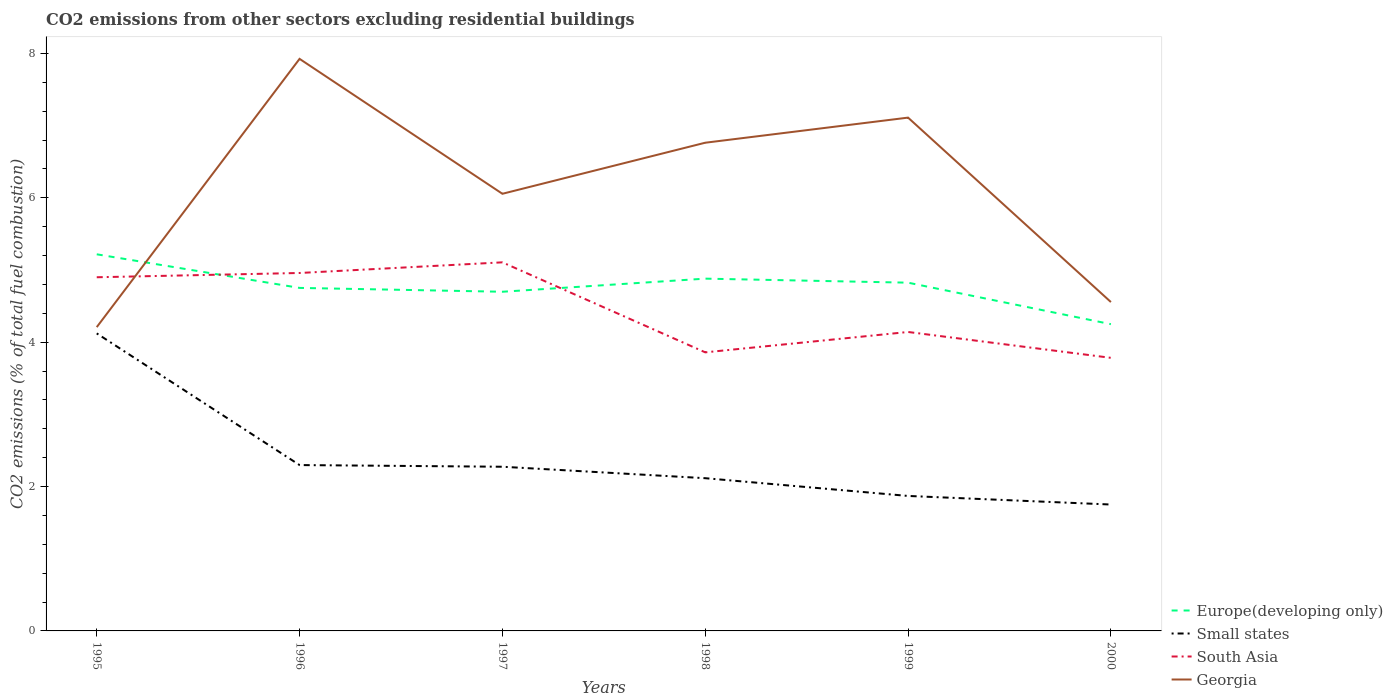Does the line corresponding to Europe(developing only) intersect with the line corresponding to Small states?
Give a very brief answer. No. Is the number of lines equal to the number of legend labels?
Ensure brevity in your answer.  Yes. Across all years, what is the maximum total CO2 emitted in Small states?
Provide a short and direct response. 1.75. In which year was the total CO2 emitted in Small states maximum?
Offer a very short reply. 2000. What is the total total CO2 emitted in South Asia in the graph?
Offer a very short reply. 0.36. What is the difference between the highest and the second highest total CO2 emitted in South Asia?
Offer a terse response. 1.32. Is the total CO2 emitted in Europe(developing only) strictly greater than the total CO2 emitted in Small states over the years?
Provide a succinct answer. No. How many lines are there?
Offer a very short reply. 4. How many years are there in the graph?
Your answer should be compact. 6. What is the difference between two consecutive major ticks on the Y-axis?
Your answer should be very brief. 2. Are the values on the major ticks of Y-axis written in scientific E-notation?
Provide a succinct answer. No. Does the graph contain any zero values?
Ensure brevity in your answer.  No. Where does the legend appear in the graph?
Give a very brief answer. Bottom right. How are the legend labels stacked?
Your answer should be very brief. Vertical. What is the title of the graph?
Provide a succinct answer. CO2 emissions from other sectors excluding residential buildings. Does "East Asia (all income levels)" appear as one of the legend labels in the graph?
Your answer should be compact. No. What is the label or title of the Y-axis?
Keep it short and to the point. CO2 emissions (% of total fuel combustion). What is the CO2 emissions (% of total fuel combustion) in Europe(developing only) in 1995?
Keep it short and to the point. 5.22. What is the CO2 emissions (% of total fuel combustion) of Small states in 1995?
Your response must be concise. 4.12. What is the CO2 emissions (% of total fuel combustion) of South Asia in 1995?
Give a very brief answer. 4.9. What is the CO2 emissions (% of total fuel combustion) in Georgia in 1995?
Your answer should be compact. 4.21. What is the CO2 emissions (% of total fuel combustion) in Europe(developing only) in 1996?
Offer a very short reply. 4.75. What is the CO2 emissions (% of total fuel combustion) in Small states in 1996?
Offer a very short reply. 2.3. What is the CO2 emissions (% of total fuel combustion) of South Asia in 1996?
Your response must be concise. 4.96. What is the CO2 emissions (% of total fuel combustion) in Georgia in 1996?
Your response must be concise. 7.92. What is the CO2 emissions (% of total fuel combustion) in Europe(developing only) in 1997?
Make the answer very short. 4.7. What is the CO2 emissions (% of total fuel combustion) in Small states in 1997?
Your answer should be very brief. 2.27. What is the CO2 emissions (% of total fuel combustion) in South Asia in 1997?
Keep it short and to the point. 5.11. What is the CO2 emissions (% of total fuel combustion) in Georgia in 1997?
Provide a succinct answer. 6.06. What is the CO2 emissions (% of total fuel combustion) of Europe(developing only) in 1998?
Provide a short and direct response. 4.88. What is the CO2 emissions (% of total fuel combustion) in Small states in 1998?
Your answer should be compact. 2.12. What is the CO2 emissions (% of total fuel combustion) of South Asia in 1998?
Provide a short and direct response. 3.86. What is the CO2 emissions (% of total fuel combustion) in Georgia in 1998?
Your answer should be compact. 6.76. What is the CO2 emissions (% of total fuel combustion) in Europe(developing only) in 1999?
Make the answer very short. 4.82. What is the CO2 emissions (% of total fuel combustion) of Small states in 1999?
Provide a short and direct response. 1.87. What is the CO2 emissions (% of total fuel combustion) of South Asia in 1999?
Give a very brief answer. 4.14. What is the CO2 emissions (% of total fuel combustion) of Georgia in 1999?
Ensure brevity in your answer.  7.11. What is the CO2 emissions (% of total fuel combustion) of Europe(developing only) in 2000?
Provide a succinct answer. 4.25. What is the CO2 emissions (% of total fuel combustion) in Small states in 2000?
Your answer should be very brief. 1.75. What is the CO2 emissions (% of total fuel combustion) of South Asia in 2000?
Your answer should be compact. 3.78. What is the CO2 emissions (% of total fuel combustion) in Georgia in 2000?
Your response must be concise. 4.56. Across all years, what is the maximum CO2 emissions (% of total fuel combustion) of Europe(developing only)?
Offer a terse response. 5.22. Across all years, what is the maximum CO2 emissions (% of total fuel combustion) in Small states?
Give a very brief answer. 4.12. Across all years, what is the maximum CO2 emissions (% of total fuel combustion) of South Asia?
Your answer should be compact. 5.11. Across all years, what is the maximum CO2 emissions (% of total fuel combustion) in Georgia?
Ensure brevity in your answer.  7.92. Across all years, what is the minimum CO2 emissions (% of total fuel combustion) in Europe(developing only)?
Your response must be concise. 4.25. Across all years, what is the minimum CO2 emissions (% of total fuel combustion) in Small states?
Your answer should be compact. 1.75. Across all years, what is the minimum CO2 emissions (% of total fuel combustion) of South Asia?
Offer a terse response. 3.78. Across all years, what is the minimum CO2 emissions (% of total fuel combustion) of Georgia?
Make the answer very short. 4.21. What is the total CO2 emissions (% of total fuel combustion) of Europe(developing only) in the graph?
Your response must be concise. 28.62. What is the total CO2 emissions (% of total fuel combustion) in Small states in the graph?
Ensure brevity in your answer.  14.43. What is the total CO2 emissions (% of total fuel combustion) of South Asia in the graph?
Provide a short and direct response. 26.74. What is the total CO2 emissions (% of total fuel combustion) in Georgia in the graph?
Provide a succinct answer. 36.61. What is the difference between the CO2 emissions (% of total fuel combustion) of Europe(developing only) in 1995 and that in 1996?
Offer a very short reply. 0.47. What is the difference between the CO2 emissions (% of total fuel combustion) of Small states in 1995 and that in 1996?
Your answer should be very brief. 1.82. What is the difference between the CO2 emissions (% of total fuel combustion) in South Asia in 1995 and that in 1996?
Offer a terse response. -0.06. What is the difference between the CO2 emissions (% of total fuel combustion) of Georgia in 1995 and that in 1996?
Offer a terse response. -3.72. What is the difference between the CO2 emissions (% of total fuel combustion) of Europe(developing only) in 1995 and that in 1997?
Offer a very short reply. 0.52. What is the difference between the CO2 emissions (% of total fuel combustion) in Small states in 1995 and that in 1997?
Your answer should be very brief. 1.85. What is the difference between the CO2 emissions (% of total fuel combustion) of South Asia in 1995 and that in 1997?
Your response must be concise. -0.21. What is the difference between the CO2 emissions (% of total fuel combustion) of Georgia in 1995 and that in 1997?
Offer a very short reply. -1.85. What is the difference between the CO2 emissions (% of total fuel combustion) of Europe(developing only) in 1995 and that in 1998?
Offer a very short reply. 0.34. What is the difference between the CO2 emissions (% of total fuel combustion) in Small states in 1995 and that in 1998?
Your response must be concise. 2.01. What is the difference between the CO2 emissions (% of total fuel combustion) in South Asia in 1995 and that in 1998?
Your answer should be compact. 1.04. What is the difference between the CO2 emissions (% of total fuel combustion) in Georgia in 1995 and that in 1998?
Provide a succinct answer. -2.55. What is the difference between the CO2 emissions (% of total fuel combustion) of Europe(developing only) in 1995 and that in 1999?
Provide a succinct answer. 0.39. What is the difference between the CO2 emissions (% of total fuel combustion) of Small states in 1995 and that in 1999?
Give a very brief answer. 2.25. What is the difference between the CO2 emissions (% of total fuel combustion) of South Asia in 1995 and that in 1999?
Give a very brief answer. 0.76. What is the difference between the CO2 emissions (% of total fuel combustion) in Georgia in 1995 and that in 1999?
Provide a succinct answer. -2.9. What is the difference between the CO2 emissions (% of total fuel combustion) of Europe(developing only) in 1995 and that in 2000?
Provide a succinct answer. 0.97. What is the difference between the CO2 emissions (% of total fuel combustion) in Small states in 1995 and that in 2000?
Your answer should be very brief. 2.37. What is the difference between the CO2 emissions (% of total fuel combustion) of South Asia in 1995 and that in 2000?
Offer a terse response. 1.12. What is the difference between the CO2 emissions (% of total fuel combustion) of Georgia in 1995 and that in 2000?
Offer a terse response. -0.35. What is the difference between the CO2 emissions (% of total fuel combustion) of Europe(developing only) in 1996 and that in 1997?
Offer a terse response. 0.05. What is the difference between the CO2 emissions (% of total fuel combustion) of Small states in 1996 and that in 1997?
Give a very brief answer. 0.02. What is the difference between the CO2 emissions (% of total fuel combustion) of South Asia in 1996 and that in 1997?
Your answer should be very brief. -0.15. What is the difference between the CO2 emissions (% of total fuel combustion) of Georgia in 1996 and that in 1997?
Keep it short and to the point. 1.87. What is the difference between the CO2 emissions (% of total fuel combustion) of Europe(developing only) in 1996 and that in 1998?
Provide a short and direct response. -0.13. What is the difference between the CO2 emissions (% of total fuel combustion) in Small states in 1996 and that in 1998?
Provide a short and direct response. 0.18. What is the difference between the CO2 emissions (% of total fuel combustion) of South Asia in 1996 and that in 1998?
Ensure brevity in your answer.  1.1. What is the difference between the CO2 emissions (% of total fuel combustion) in Georgia in 1996 and that in 1998?
Give a very brief answer. 1.16. What is the difference between the CO2 emissions (% of total fuel combustion) of Europe(developing only) in 1996 and that in 1999?
Your answer should be very brief. -0.07. What is the difference between the CO2 emissions (% of total fuel combustion) in Small states in 1996 and that in 1999?
Offer a very short reply. 0.43. What is the difference between the CO2 emissions (% of total fuel combustion) in South Asia in 1996 and that in 1999?
Keep it short and to the point. 0.82. What is the difference between the CO2 emissions (% of total fuel combustion) of Georgia in 1996 and that in 1999?
Your response must be concise. 0.81. What is the difference between the CO2 emissions (% of total fuel combustion) of Europe(developing only) in 1996 and that in 2000?
Offer a very short reply. 0.5. What is the difference between the CO2 emissions (% of total fuel combustion) of Small states in 1996 and that in 2000?
Offer a very short reply. 0.55. What is the difference between the CO2 emissions (% of total fuel combustion) of South Asia in 1996 and that in 2000?
Give a very brief answer. 1.18. What is the difference between the CO2 emissions (% of total fuel combustion) of Georgia in 1996 and that in 2000?
Give a very brief answer. 3.37. What is the difference between the CO2 emissions (% of total fuel combustion) in Europe(developing only) in 1997 and that in 1998?
Offer a very short reply. -0.18. What is the difference between the CO2 emissions (% of total fuel combustion) of Small states in 1997 and that in 1998?
Offer a terse response. 0.16. What is the difference between the CO2 emissions (% of total fuel combustion) of South Asia in 1997 and that in 1998?
Offer a very short reply. 1.25. What is the difference between the CO2 emissions (% of total fuel combustion) in Georgia in 1997 and that in 1998?
Your answer should be very brief. -0.71. What is the difference between the CO2 emissions (% of total fuel combustion) of Europe(developing only) in 1997 and that in 1999?
Give a very brief answer. -0.13. What is the difference between the CO2 emissions (% of total fuel combustion) of Small states in 1997 and that in 1999?
Give a very brief answer. 0.4. What is the difference between the CO2 emissions (% of total fuel combustion) of South Asia in 1997 and that in 1999?
Ensure brevity in your answer.  0.96. What is the difference between the CO2 emissions (% of total fuel combustion) of Georgia in 1997 and that in 1999?
Your response must be concise. -1.05. What is the difference between the CO2 emissions (% of total fuel combustion) in Europe(developing only) in 1997 and that in 2000?
Keep it short and to the point. 0.45. What is the difference between the CO2 emissions (% of total fuel combustion) of Small states in 1997 and that in 2000?
Offer a terse response. 0.52. What is the difference between the CO2 emissions (% of total fuel combustion) in South Asia in 1997 and that in 2000?
Make the answer very short. 1.32. What is the difference between the CO2 emissions (% of total fuel combustion) of Georgia in 1997 and that in 2000?
Your answer should be compact. 1.5. What is the difference between the CO2 emissions (% of total fuel combustion) in Europe(developing only) in 1998 and that in 1999?
Provide a short and direct response. 0.06. What is the difference between the CO2 emissions (% of total fuel combustion) in Small states in 1998 and that in 1999?
Your answer should be very brief. 0.25. What is the difference between the CO2 emissions (% of total fuel combustion) in South Asia in 1998 and that in 1999?
Keep it short and to the point. -0.28. What is the difference between the CO2 emissions (% of total fuel combustion) of Georgia in 1998 and that in 1999?
Offer a very short reply. -0.35. What is the difference between the CO2 emissions (% of total fuel combustion) of Europe(developing only) in 1998 and that in 2000?
Provide a succinct answer. 0.63. What is the difference between the CO2 emissions (% of total fuel combustion) in Small states in 1998 and that in 2000?
Your answer should be compact. 0.36. What is the difference between the CO2 emissions (% of total fuel combustion) of South Asia in 1998 and that in 2000?
Offer a terse response. 0.08. What is the difference between the CO2 emissions (% of total fuel combustion) of Georgia in 1998 and that in 2000?
Make the answer very short. 2.21. What is the difference between the CO2 emissions (% of total fuel combustion) in Europe(developing only) in 1999 and that in 2000?
Give a very brief answer. 0.57. What is the difference between the CO2 emissions (% of total fuel combustion) in Small states in 1999 and that in 2000?
Your answer should be compact. 0.12. What is the difference between the CO2 emissions (% of total fuel combustion) of South Asia in 1999 and that in 2000?
Your answer should be very brief. 0.36. What is the difference between the CO2 emissions (% of total fuel combustion) of Georgia in 1999 and that in 2000?
Your answer should be compact. 2.55. What is the difference between the CO2 emissions (% of total fuel combustion) in Europe(developing only) in 1995 and the CO2 emissions (% of total fuel combustion) in Small states in 1996?
Provide a succinct answer. 2.92. What is the difference between the CO2 emissions (% of total fuel combustion) in Europe(developing only) in 1995 and the CO2 emissions (% of total fuel combustion) in South Asia in 1996?
Provide a short and direct response. 0.26. What is the difference between the CO2 emissions (% of total fuel combustion) in Europe(developing only) in 1995 and the CO2 emissions (% of total fuel combustion) in Georgia in 1996?
Offer a terse response. -2.71. What is the difference between the CO2 emissions (% of total fuel combustion) of Small states in 1995 and the CO2 emissions (% of total fuel combustion) of South Asia in 1996?
Make the answer very short. -0.84. What is the difference between the CO2 emissions (% of total fuel combustion) in Small states in 1995 and the CO2 emissions (% of total fuel combustion) in Georgia in 1996?
Ensure brevity in your answer.  -3.8. What is the difference between the CO2 emissions (% of total fuel combustion) of South Asia in 1995 and the CO2 emissions (% of total fuel combustion) of Georgia in 1996?
Ensure brevity in your answer.  -3.03. What is the difference between the CO2 emissions (% of total fuel combustion) of Europe(developing only) in 1995 and the CO2 emissions (% of total fuel combustion) of Small states in 1997?
Your answer should be compact. 2.94. What is the difference between the CO2 emissions (% of total fuel combustion) in Europe(developing only) in 1995 and the CO2 emissions (% of total fuel combustion) in South Asia in 1997?
Make the answer very short. 0.11. What is the difference between the CO2 emissions (% of total fuel combustion) of Europe(developing only) in 1995 and the CO2 emissions (% of total fuel combustion) of Georgia in 1997?
Your response must be concise. -0.84. What is the difference between the CO2 emissions (% of total fuel combustion) of Small states in 1995 and the CO2 emissions (% of total fuel combustion) of South Asia in 1997?
Your response must be concise. -0.98. What is the difference between the CO2 emissions (% of total fuel combustion) of Small states in 1995 and the CO2 emissions (% of total fuel combustion) of Georgia in 1997?
Keep it short and to the point. -1.93. What is the difference between the CO2 emissions (% of total fuel combustion) of South Asia in 1995 and the CO2 emissions (% of total fuel combustion) of Georgia in 1997?
Provide a succinct answer. -1.16. What is the difference between the CO2 emissions (% of total fuel combustion) of Europe(developing only) in 1995 and the CO2 emissions (% of total fuel combustion) of Small states in 1998?
Keep it short and to the point. 3.1. What is the difference between the CO2 emissions (% of total fuel combustion) of Europe(developing only) in 1995 and the CO2 emissions (% of total fuel combustion) of South Asia in 1998?
Provide a succinct answer. 1.36. What is the difference between the CO2 emissions (% of total fuel combustion) of Europe(developing only) in 1995 and the CO2 emissions (% of total fuel combustion) of Georgia in 1998?
Give a very brief answer. -1.55. What is the difference between the CO2 emissions (% of total fuel combustion) of Small states in 1995 and the CO2 emissions (% of total fuel combustion) of South Asia in 1998?
Offer a terse response. 0.26. What is the difference between the CO2 emissions (% of total fuel combustion) of Small states in 1995 and the CO2 emissions (% of total fuel combustion) of Georgia in 1998?
Ensure brevity in your answer.  -2.64. What is the difference between the CO2 emissions (% of total fuel combustion) of South Asia in 1995 and the CO2 emissions (% of total fuel combustion) of Georgia in 1998?
Your answer should be compact. -1.86. What is the difference between the CO2 emissions (% of total fuel combustion) of Europe(developing only) in 1995 and the CO2 emissions (% of total fuel combustion) of Small states in 1999?
Provide a short and direct response. 3.35. What is the difference between the CO2 emissions (% of total fuel combustion) of Europe(developing only) in 1995 and the CO2 emissions (% of total fuel combustion) of South Asia in 1999?
Make the answer very short. 1.08. What is the difference between the CO2 emissions (% of total fuel combustion) of Europe(developing only) in 1995 and the CO2 emissions (% of total fuel combustion) of Georgia in 1999?
Your response must be concise. -1.89. What is the difference between the CO2 emissions (% of total fuel combustion) in Small states in 1995 and the CO2 emissions (% of total fuel combustion) in South Asia in 1999?
Provide a short and direct response. -0.02. What is the difference between the CO2 emissions (% of total fuel combustion) in Small states in 1995 and the CO2 emissions (% of total fuel combustion) in Georgia in 1999?
Provide a short and direct response. -2.99. What is the difference between the CO2 emissions (% of total fuel combustion) of South Asia in 1995 and the CO2 emissions (% of total fuel combustion) of Georgia in 1999?
Give a very brief answer. -2.21. What is the difference between the CO2 emissions (% of total fuel combustion) in Europe(developing only) in 1995 and the CO2 emissions (% of total fuel combustion) in Small states in 2000?
Your answer should be very brief. 3.47. What is the difference between the CO2 emissions (% of total fuel combustion) of Europe(developing only) in 1995 and the CO2 emissions (% of total fuel combustion) of South Asia in 2000?
Offer a very short reply. 1.43. What is the difference between the CO2 emissions (% of total fuel combustion) in Europe(developing only) in 1995 and the CO2 emissions (% of total fuel combustion) in Georgia in 2000?
Your answer should be very brief. 0.66. What is the difference between the CO2 emissions (% of total fuel combustion) in Small states in 1995 and the CO2 emissions (% of total fuel combustion) in South Asia in 2000?
Your answer should be compact. 0.34. What is the difference between the CO2 emissions (% of total fuel combustion) in Small states in 1995 and the CO2 emissions (% of total fuel combustion) in Georgia in 2000?
Make the answer very short. -0.43. What is the difference between the CO2 emissions (% of total fuel combustion) in South Asia in 1995 and the CO2 emissions (% of total fuel combustion) in Georgia in 2000?
Make the answer very short. 0.34. What is the difference between the CO2 emissions (% of total fuel combustion) of Europe(developing only) in 1996 and the CO2 emissions (% of total fuel combustion) of Small states in 1997?
Make the answer very short. 2.48. What is the difference between the CO2 emissions (% of total fuel combustion) of Europe(developing only) in 1996 and the CO2 emissions (% of total fuel combustion) of South Asia in 1997?
Keep it short and to the point. -0.35. What is the difference between the CO2 emissions (% of total fuel combustion) of Europe(developing only) in 1996 and the CO2 emissions (% of total fuel combustion) of Georgia in 1997?
Your response must be concise. -1.3. What is the difference between the CO2 emissions (% of total fuel combustion) in Small states in 1996 and the CO2 emissions (% of total fuel combustion) in South Asia in 1997?
Make the answer very short. -2.81. What is the difference between the CO2 emissions (% of total fuel combustion) of Small states in 1996 and the CO2 emissions (% of total fuel combustion) of Georgia in 1997?
Provide a succinct answer. -3.76. What is the difference between the CO2 emissions (% of total fuel combustion) of South Asia in 1996 and the CO2 emissions (% of total fuel combustion) of Georgia in 1997?
Your answer should be very brief. -1.1. What is the difference between the CO2 emissions (% of total fuel combustion) of Europe(developing only) in 1996 and the CO2 emissions (% of total fuel combustion) of Small states in 1998?
Offer a terse response. 2.64. What is the difference between the CO2 emissions (% of total fuel combustion) in Europe(developing only) in 1996 and the CO2 emissions (% of total fuel combustion) in South Asia in 1998?
Offer a very short reply. 0.89. What is the difference between the CO2 emissions (% of total fuel combustion) in Europe(developing only) in 1996 and the CO2 emissions (% of total fuel combustion) in Georgia in 1998?
Give a very brief answer. -2.01. What is the difference between the CO2 emissions (% of total fuel combustion) of Small states in 1996 and the CO2 emissions (% of total fuel combustion) of South Asia in 1998?
Your answer should be very brief. -1.56. What is the difference between the CO2 emissions (% of total fuel combustion) of Small states in 1996 and the CO2 emissions (% of total fuel combustion) of Georgia in 1998?
Offer a very short reply. -4.46. What is the difference between the CO2 emissions (% of total fuel combustion) in South Asia in 1996 and the CO2 emissions (% of total fuel combustion) in Georgia in 1998?
Offer a terse response. -1.8. What is the difference between the CO2 emissions (% of total fuel combustion) of Europe(developing only) in 1996 and the CO2 emissions (% of total fuel combustion) of Small states in 1999?
Provide a succinct answer. 2.88. What is the difference between the CO2 emissions (% of total fuel combustion) in Europe(developing only) in 1996 and the CO2 emissions (% of total fuel combustion) in South Asia in 1999?
Provide a short and direct response. 0.61. What is the difference between the CO2 emissions (% of total fuel combustion) of Europe(developing only) in 1996 and the CO2 emissions (% of total fuel combustion) of Georgia in 1999?
Provide a short and direct response. -2.36. What is the difference between the CO2 emissions (% of total fuel combustion) in Small states in 1996 and the CO2 emissions (% of total fuel combustion) in South Asia in 1999?
Ensure brevity in your answer.  -1.84. What is the difference between the CO2 emissions (% of total fuel combustion) of Small states in 1996 and the CO2 emissions (% of total fuel combustion) of Georgia in 1999?
Give a very brief answer. -4.81. What is the difference between the CO2 emissions (% of total fuel combustion) of South Asia in 1996 and the CO2 emissions (% of total fuel combustion) of Georgia in 1999?
Your answer should be compact. -2.15. What is the difference between the CO2 emissions (% of total fuel combustion) of Europe(developing only) in 1996 and the CO2 emissions (% of total fuel combustion) of Small states in 2000?
Your answer should be very brief. 3. What is the difference between the CO2 emissions (% of total fuel combustion) of Europe(developing only) in 1996 and the CO2 emissions (% of total fuel combustion) of South Asia in 2000?
Offer a terse response. 0.97. What is the difference between the CO2 emissions (% of total fuel combustion) in Europe(developing only) in 1996 and the CO2 emissions (% of total fuel combustion) in Georgia in 2000?
Your answer should be compact. 0.2. What is the difference between the CO2 emissions (% of total fuel combustion) of Small states in 1996 and the CO2 emissions (% of total fuel combustion) of South Asia in 2000?
Offer a terse response. -1.49. What is the difference between the CO2 emissions (% of total fuel combustion) of Small states in 1996 and the CO2 emissions (% of total fuel combustion) of Georgia in 2000?
Offer a very short reply. -2.26. What is the difference between the CO2 emissions (% of total fuel combustion) in South Asia in 1996 and the CO2 emissions (% of total fuel combustion) in Georgia in 2000?
Your answer should be compact. 0.4. What is the difference between the CO2 emissions (% of total fuel combustion) of Europe(developing only) in 1997 and the CO2 emissions (% of total fuel combustion) of Small states in 1998?
Your response must be concise. 2.58. What is the difference between the CO2 emissions (% of total fuel combustion) in Europe(developing only) in 1997 and the CO2 emissions (% of total fuel combustion) in South Asia in 1998?
Provide a short and direct response. 0.84. What is the difference between the CO2 emissions (% of total fuel combustion) in Europe(developing only) in 1997 and the CO2 emissions (% of total fuel combustion) in Georgia in 1998?
Offer a terse response. -2.06. What is the difference between the CO2 emissions (% of total fuel combustion) in Small states in 1997 and the CO2 emissions (% of total fuel combustion) in South Asia in 1998?
Keep it short and to the point. -1.58. What is the difference between the CO2 emissions (% of total fuel combustion) of Small states in 1997 and the CO2 emissions (% of total fuel combustion) of Georgia in 1998?
Make the answer very short. -4.49. What is the difference between the CO2 emissions (% of total fuel combustion) of South Asia in 1997 and the CO2 emissions (% of total fuel combustion) of Georgia in 1998?
Your answer should be very brief. -1.66. What is the difference between the CO2 emissions (% of total fuel combustion) of Europe(developing only) in 1997 and the CO2 emissions (% of total fuel combustion) of Small states in 1999?
Ensure brevity in your answer.  2.83. What is the difference between the CO2 emissions (% of total fuel combustion) of Europe(developing only) in 1997 and the CO2 emissions (% of total fuel combustion) of South Asia in 1999?
Offer a very short reply. 0.56. What is the difference between the CO2 emissions (% of total fuel combustion) in Europe(developing only) in 1997 and the CO2 emissions (% of total fuel combustion) in Georgia in 1999?
Offer a terse response. -2.41. What is the difference between the CO2 emissions (% of total fuel combustion) of Small states in 1997 and the CO2 emissions (% of total fuel combustion) of South Asia in 1999?
Provide a short and direct response. -1.87. What is the difference between the CO2 emissions (% of total fuel combustion) of Small states in 1997 and the CO2 emissions (% of total fuel combustion) of Georgia in 1999?
Ensure brevity in your answer.  -4.84. What is the difference between the CO2 emissions (% of total fuel combustion) of South Asia in 1997 and the CO2 emissions (% of total fuel combustion) of Georgia in 1999?
Your answer should be compact. -2. What is the difference between the CO2 emissions (% of total fuel combustion) of Europe(developing only) in 1997 and the CO2 emissions (% of total fuel combustion) of Small states in 2000?
Provide a short and direct response. 2.95. What is the difference between the CO2 emissions (% of total fuel combustion) of Europe(developing only) in 1997 and the CO2 emissions (% of total fuel combustion) of South Asia in 2000?
Your answer should be compact. 0.92. What is the difference between the CO2 emissions (% of total fuel combustion) in Europe(developing only) in 1997 and the CO2 emissions (% of total fuel combustion) in Georgia in 2000?
Offer a terse response. 0.14. What is the difference between the CO2 emissions (% of total fuel combustion) in Small states in 1997 and the CO2 emissions (% of total fuel combustion) in South Asia in 2000?
Provide a short and direct response. -1.51. What is the difference between the CO2 emissions (% of total fuel combustion) in Small states in 1997 and the CO2 emissions (% of total fuel combustion) in Georgia in 2000?
Provide a short and direct response. -2.28. What is the difference between the CO2 emissions (% of total fuel combustion) in South Asia in 1997 and the CO2 emissions (% of total fuel combustion) in Georgia in 2000?
Make the answer very short. 0.55. What is the difference between the CO2 emissions (% of total fuel combustion) in Europe(developing only) in 1998 and the CO2 emissions (% of total fuel combustion) in Small states in 1999?
Provide a succinct answer. 3.01. What is the difference between the CO2 emissions (% of total fuel combustion) of Europe(developing only) in 1998 and the CO2 emissions (% of total fuel combustion) of South Asia in 1999?
Give a very brief answer. 0.74. What is the difference between the CO2 emissions (% of total fuel combustion) of Europe(developing only) in 1998 and the CO2 emissions (% of total fuel combustion) of Georgia in 1999?
Provide a succinct answer. -2.23. What is the difference between the CO2 emissions (% of total fuel combustion) of Small states in 1998 and the CO2 emissions (% of total fuel combustion) of South Asia in 1999?
Give a very brief answer. -2.03. What is the difference between the CO2 emissions (% of total fuel combustion) in Small states in 1998 and the CO2 emissions (% of total fuel combustion) in Georgia in 1999?
Offer a very short reply. -4.99. What is the difference between the CO2 emissions (% of total fuel combustion) of South Asia in 1998 and the CO2 emissions (% of total fuel combustion) of Georgia in 1999?
Keep it short and to the point. -3.25. What is the difference between the CO2 emissions (% of total fuel combustion) of Europe(developing only) in 1998 and the CO2 emissions (% of total fuel combustion) of Small states in 2000?
Ensure brevity in your answer.  3.13. What is the difference between the CO2 emissions (% of total fuel combustion) in Europe(developing only) in 1998 and the CO2 emissions (% of total fuel combustion) in South Asia in 2000?
Offer a very short reply. 1.1. What is the difference between the CO2 emissions (% of total fuel combustion) of Europe(developing only) in 1998 and the CO2 emissions (% of total fuel combustion) of Georgia in 2000?
Provide a short and direct response. 0.32. What is the difference between the CO2 emissions (% of total fuel combustion) in Small states in 1998 and the CO2 emissions (% of total fuel combustion) in South Asia in 2000?
Give a very brief answer. -1.67. What is the difference between the CO2 emissions (% of total fuel combustion) of Small states in 1998 and the CO2 emissions (% of total fuel combustion) of Georgia in 2000?
Your answer should be compact. -2.44. What is the difference between the CO2 emissions (% of total fuel combustion) of South Asia in 1998 and the CO2 emissions (% of total fuel combustion) of Georgia in 2000?
Provide a short and direct response. -0.7. What is the difference between the CO2 emissions (% of total fuel combustion) of Europe(developing only) in 1999 and the CO2 emissions (% of total fuel combustion) of Small states in 2000?
Make the answer very short. 3.07. What is the difference between the CO2 emissions (% of total fuel combustion) in Europe(developing only) in 1999 and the CO2 emissions (% of total fuel combustion) in South Asia in 2000?
Offer a terse response. 1.04. What is the difference between the CO2 emissions (% of total fuel combustion) in Europe(developing only) in 1999 and the CO2 emissions (% of total fuel combustion) in Georgia in 2000?
Make the answer very short. 0.27. What is the difference between the CO2 emissions (% of total fuel combustion) of Small states in 1999 and the CO2 emissions (% of total fuel combustion) of South Asia in 2000?
Your response must be concise. -1.91. What is the difference between the CO2 emissions (% of total fuel combustion) in Small states in 1999 and the CO2 emissions (% of total fuel combustion) in Georgia in 2000?
Give a very brief answer. -2.69. What is the difference between the CO2 emissions (% of total fuel combustion) of South Asia in 1999 and the CO2 emissions (% of total fuel combustion) of Georgia in 2000?
Provide a short and direct response. -0.41. What is the average CO2 emissions (% of total fuel combustion) of Europe(developing only) per year?
Provide a succinct answer. 4.77. What is the average CO2 emissions (% of total fuel combustion) in Small states per year?
Make the answer very short. 2.4. What is the average CO2 emissions (% of total fuel combustion) in South Asia per year?
Give a very brief answer. 4.46. What is the average CO2 emissions (% of total fuel combustion) in Georgia per year?
Your response must be concise. 6.1. In the year 1995, what is the difference between the CO2 emissions (% of total fuel combustion) of Europe(developing only) and CO2 emissions (% of total fuel combustion) of Small states?
Provide a succinct answer. 1.1. In the year 1995, what is the difference between the CO2 emissions (% of total fuel combustion) in Europe(developing only) and CO2 emissions (% of total fuel combustion) in South Asia?
Ensure brevity in your answer.  0.32. In the year 1995, what is the difference between the CO2 emissions (% of total fuel combustion) in Europe(developing only) and CO2 emissions (% of total fuel combustion) in Georgia?
Provide a succinct answer. 1.01. In the year 1995, what is the difference between the CO2 emissions (% of total fuel combustion) in Small states and CO2 emissions (% of total fuel combustion) in South Asia?
Give a very brief answer. -0.78. In the year 1995, what is the difference between the CO2 emissions (% of total fuel combustion) of Small states and CO2 emissions (% of total fuel combustion) of Georgia?
Provide a succinct answer. -0.09. In the year 1995, what is the difference between the CO2 emissions (% of total fuel combustion) in South Asia and CO2 emissions (% of total fuel combustion) in Georgia?
Offer a terse response. 0.69. In the year 1996, what is the difference between the CO2 emissions (% of total fuel combustion) of Europe(developing only) and CO2 emissions (% of total fuel combustion) of Small states?
Your answer should be very brief. 2.45. In the year 1996, what is the difference between the CO2 emissions (% of total fuel combustion) in Europe(developing only) and CO2 emissions (% of total fuel combustion) in South Asia?
Make the answer very short. -0.21. In the year 1996, what is the difference between the CO2 emissions (% of total fuel combustion) in Europe(developing only) and CO2 emissions (% of total fuel combustion) in Georgia?
Your answer should be compact. -3.17. In the year 1996, what is the difference between the CO2 emissions (% of total fuel combustion) of Small states and CO2 emissions (% of total fuel combustion) of South Asia?
Your response must be concise. -2.66. In the year 1996, what is the difference between the CO2 emissions (% of total fuel combustion) of Small states and CO2 emissions (% of total fuel combustion) of Georgia?
Your response must be concise. -5.63. In the year 1996, what is the difference between the CO2 emissions (% of total fuel combustion) of South Asia and CO2 emissions (% of total fuel combustion) of Georgia?
Your answer should be very brief. -2.97. In the year 1997, what is the difference between the CO2 emissions (% of total fuel combustion) in Europe(developing only) and CO2 emissions (% of total fuel combustion) in Small states?
Your answer should be very brief. 2.42. In the year 1997, what is the difference between the CO2 emissions (% of total fuel combustion) in Europe(developing only) and CO2 emissions (% of total fuel combustion) in South Asia?
Your answer should be compact. -0.41. In the year 1997, what is the difference between the CO2 emissions (% of total fuel combustion) in Europe(developing only) and CO2 emissions (% of total fuel combustion) in Georgia?
Offer a very short reply. -1.36. In the year 1997, what is the difference between the CO2 emissions (% of total fuel combustion) in Small states and CO2 emissions (% of total fuel combustion) in South Asia?
Your answer should be compact. -2.83. In the year 1997, what is the difference between the CO2 emissions (% of total fuel combustion) of Small states and CO2 emissions (% of total fuel combustion) of Georgia?
Your response must be concise. -3.78. In the year 1997, what is the difference between the CO2 emissions (% of total fuel combustion) in South Asia and CO2 emissions (% of total fuel combustion) in Georgia?
Offer a very short reply. -0.95. In the year 1998, what is the difference between the CO2 emissions (% of total fuel combustion) in Europe(developing only) and CO2 emissions (% of total fuel combustion) in Small states?
Keep it short and to the point. 2.76. In the year 1998, what is the difference between the CO2 emissions (% of total fuel combustion) in Europe(developing only) and CO2 emissions (% of total fuel combustion) in South Asia?
Offer a terse response. 1.02. In the year 1998, what is the difference between the CO2 emissions (% of total fuel combustion) of Europe(developing only) and CO2 emissions (% of total fuel combustion) of Georgia?
Ensure brevity in your answer.  -1.88. In the year 1998, what is the difference between the CO2 emissions (% of total fuel combustion) of Small states and CO2 emissions (% of total fuel combustion) of South Asia?
Offer a terse response. -1.74. In the year 1998, what is the difference between the CO2 emissions (% of total fuel combustion) in Small states and CO2 emissions (% of total fuel combustion) in Georgia?
Your response must be concise. -4.65. In the year 1998, what is the difference between the CO2 emissions (% of total fuel combustion) in South Asia and CO2 emissions (% of total fuel combustion) in Georgia?
Offer a terse response. -2.9. In the year 1999, what is the difference between the CO2 emissions (% of total fuel combustion) in Europe(developing only) and CO2 emissions (% of total fuel combustion) in Small states?
Offer a very short reply. 2.95. In the year 1999, what is the difference between the CO2 emissions (% of total fuel combustion) in Europe(developing only) and CO2 emissions (% of total fuel combustion) in South Asia?
Ensure brevity in your answer.  0.68. In the year 1999, what is the difference between the CO2 emissions (% of total fuel combustion) of Europe(developing only) and CO2 emissions (% of total fuel combustion) of Georgia?
Make the answer very short. -2.29. In the year 1999, what is the difference between the CO2 emissions (% of total fuel combustion) of Small states and CO2 emissions (% of total fuel combustion) of South Asia?
Provide a short and direct response. -2.27. In the year 1999, what is the difference between the CO2 emissions (% of total fuel combustion) of Small states and CO2 emissions (% of total fuel combustion) of Georgia?
Your answer should be very brief. -5.24. In the year 1999, what is the difference between the CO2 emissions (% of total fuel combustion) in South Asia and CO2 emissions (% of total fuel combustion) in Georgia?
Your response must be concise. -2.97. In the year 2000, what is the difference between the CO2 emissions (% of total fuel combustion) of Europe(developing only) and CO2 emissions (% of total fuel combustion) of Small states?
Ensure brevity in your answer.  2.5. In the year 2000, what is the difference between the CO2 emissions (% of total fuel combustion) of Europe(developing only) and CO2 emissions (% of total fuel combustion) of South Asia?
Give a very brief answer. 0.47. In the year 2000, what is the difference between the CO2 emissions (% of total fuel combustion) in Europe(developing only) and CO2 emissions (% of total fuel combustion) in Georgia?
Provide a short and direct response. -0.31. In the year 2000, what is the difference between the CO2 emissions (% of total fuel combustion) of Small states and CO2 emissions (% of total fuel combustion) of South Asia?
Offer a very short reply. -2.03. In the year 2000, what is the difference between the CO2 emissions (% of total fuel combustion) in Small states and CO2 emissions (% of total fuel combustion) in Georgia?
Give a very brief answer. -2.8. In the year 2000, what is the difference between the CO2 emissions (% of total fuel combustion) of South Asia and CO2 emissions (% of total fuel combustion) of Georgia?
Your response must be concise. -0.77. What is the ratio of the CO2 emissions (% of total fuel combustion) of Europe(developing only) in 1995 to that in 1996?
Ensure brevity in your answer.  1.1. What is the ratio of the CO2 emissions (% of total fuel combustion) of Small states in 1995 to that in 1996?
Give a very brief answer. 1.79. What is the ratio of the CO2 emissions (% of total fuel combustion) in Georgia in 1995 to that in 1996?
Your response must be concise. 0.53. What is the ratio of the CO2 emissions (% of total fuel combustion) in Europe(developing only) in 1995 to that in 1997?
Your answer should be compact. 1.11. What is the ratio of the CO2 emissions (% of total fuel combustion) in Small states in 1995 to that in 1997?
Offer a terse response. 1.81. What is the ratio of the CO2 emissions (% of total fuel combustion) in South Asia in 1995 to that in 1997?
Ensure brevity in your answer.  0.96. What is the ratio of the CO2 emissions (% of total fuel combustion) in Georgia in 1995 to that in 1997?
Your answer should be compact. 0.69. What is the ratio of the CO2 emissions (% of total fuel combustion) in Europe(developing only) in 1995 to that in 1998?
Your response must be concise. 1.07. What is the ratio of the CO2 emissions (% of total fuel combustion) in Small states in 1995 to that in 1998?
Your answer should be compact. 1.95. What is the ratio of the CO2 emissions (% of total fuel combustion) of South Asia in 1995 to that in 1998?
Provide a succinct answer. 1.27. What is the ratio of the CO2 emissions (% of total fuel combustion) in Georgia in 1995 to that in 1998?
Offer a terse response. 0.62. What is the ratio of the CO2 emissions (% of total fuel combustion) in Europe(developing only) in 1995 to that in 1999?
Keep it short and to the point. 1.08. What is the ratio of the CO2 emissions (% of total fuel combustion) of Small states in 1995 to that in 1999?
Ensure brevity in your answer.  2.2. What is the ratio of the CO2 emissions (% of total fuel combustion) in South Asia in 1995 to that in 1999?
Offer a terse response. 1.18. What is the ratio of the CO2 emissions (% of total fuel combustion) in Georgia in 1995 to that in 1999?
Your answer should be very brief. 0.59. What is the ratio of the CO2 emissions (% of total fuel combustion) in Europe(developing only) in 1995 to that in 2000?
Provide a succinct answer. 1.23. What is the ratio of the CO2 emissions (% of total fuel combustion) in Small states in 1995 to that in 2000?
Keep it short and to the point. 2.35. What is the ratio of the CO2 emissions (% of total fuel combustion) of South Asia in 1995 to that in 2000?
Your answer should be compact. 1.3. What is the ratio of the CO2 emissions (% of total fuel combustion) of Georgia in 1995 to that in 2000?
Your answer should be very brief. 0.92. What is the ratio of the CO2 emissions (% of total fuel combustion) in Europe(developing only) in 1996 to that in 1997?
Your answer should be compact. 1.01. What is the ratio of the CO2 emissions (% of total fuel combustion) of Small states in 1996 to that in 1997?
Your response must be concise. 1.01. What is the ratio of the CO2 emissions (% of total fuel combustion) of South Asia in 1996 to that in 1997?
Your answer should be compact. 0.97. What is the ratio of the CO2 emissions (% of total fuel combustion) of Georgia in 1996 to that in 1997?
Provide a short and direct response. 1.31. What is the ratio of the CO2 emissions (% of total fuel combustion) of Europe(developing only) in 1996 to that in 1998?
Keep it short and to the point. 0.97. What is the ratio of the CO2 emissions (% of total fuel combustion) in Small states in 1996 to that in 1998?
Keep it short and to the point. 1.09. What is the ratio of the CO2 emissions (% of total fuel combustion) in South Asia in 1996 to that in 1998?
Your response must be concise. 1.28. What is the ratio of the CO2 emissions (% of total fuel combustion) of Georgia in 1996 to that in 1998?
Your answer should be compact. 1.17. What is the ratio of the CO2 emissions (% of total fuel combustion) of Europe(developing only) in 1996 to that in 1999?
Provide a succinct answer. 0.98. What is the ratio of the CO2 emissions (% of total fuel combustion) in Small states in 1996 to that in 1999?
Offer a very short reply. 1.23. What is the ratio of the CO2 emissions (% of total fuel combustion) in South Asia in 1996 to that in 1999?
Make the answer very short. 1.2. What is the ratio of the CO2 emissions (% of total fuel combustion) in Georgia in 1996 to that in 1999?
Provide a succinct answer. 1.11. What is the ratio of the CO2 emissions (% of total fuel combustion) in Europe(developing only) in 1996 to that in 2000?
Your answer should be very brief. 1.12. What is the ratio of the CO2 emissions (% of total fuel combustion) in Small states in 1996 to that in 2000?
Offer a very short reply. 1.31. What is the ratio of the CO2 emissions (% of total fuel combustion) of South Asia in 1996 to that in 2000?
Your response must be concise. 1.31. What is the ratio of the CO2 emissions (% of total fuel combustion) of Georgia in 1996 to that in 2000?
Your answer should be compact. 1.74. What is the ratio of the CO2 emissions (% of total fuel combustion) in Europe(developing only) in 1997 to that in 1998?
Offer a very short reply. 0.96. What is the ratio of the CO2 emissions (% of total fuel combustion) of Small states in 1997 to that in 1998?
Your answer should be compact. 1.07. What is the ratio of the CO2 emissions (% of total fuel combustion) of South Asia in 1997 to that in 1998?
Your answer should be compact. 1.32. What is the ratio of the CO2 emissions (% of total fuel combustion) in Georgia in 1997 to that in 1998?
Provide a short and direct response. 0.9. What is the ratio of the CO2 emissions (% of total fuel combustion) in Europe(developing only) in 1997 to that in 1999?
Keep it short and to the point. 0.97. What is the ratio of the CO2 emissions (% of total fuel combustion) in Small states in 1997 to that in 1999?
Ensure brevity in your answer.  1.22. What is the ratio of the CO2 emissions (% of total fuel combustion) of South Asia in 1997 to that in 1999?
Offer a terse response. 1.23. What is the ratio of the CO2 emissions (% of total fuel combustion) of Georgia in 1997 to that in 1999?
Your answer should be very brief. 0.85. What is the ratio of the CO2 emissions (% of total fuel combustion) of Europe(developing only) in 1997 to that in 2000?
Your answer should be compact. 1.11. What is the ratio of the CO2 emissions (% of total fuel combustion) of Small states in 1997 to that in 2000?
Your answer should be very brief. 1.3. What is the ratio of the CO2 emissions (% of total fuel combustion) of South Asia in 1997 to that in 2000?
Give a very brief answer. 1.35. What is the ratio of the CO2 emissions (% of total fuel combustion) of Georgia in 1997 to that in 2000?
Provide a short and direct response. 1.33. What is the ratio of the CO2 emissions (% of total fuel combustion) in Europe(developing only) in 1998 to that in 1999?
Give a very brief answer. 1.01. What is the ratio of the CO2 emissions (% of total fuel combustion) in Small states in 1998 to that in 1999?
Your answer should be very brief. 1.13. What is the ratio of the CO2 emissions (% of total fuel combustion) in South Asia in 1998 to that in 1999?
Offer a terse response. 0.93. What is the ratio of the CO2 emissions (% of total fuel combustion) in Georgia in 1998 to that in 1999?
Offer a very short reply. 0.95. What is the ratio of the CO2 emissions (% of total fuel combustion) of Europe(developing only) in 1998 to that in 2000?
Provide a succinct answer. 1.15. What is the ratio of the CO2 emissions (% of total fuel combustion) in Small states in 1998 to that in 2000?
Your answer should be compact. 1.21. What is the ratio of the CO2 emissions (% of total fuel combustion) of South Asia in 1998 to that in 2000?
Your answer should be very brief. 1.02. What is the ratio of the CO2 emissions (% of total fuel combustion) of Georgia in 1998 to that in 2000?
Offer a terse response. 1.48. What is the ratio of the CO2 emissions (% of total fuel combustion) in Europe(developing only) in 1999 to that in 2000?
Give a very brief answer. 1.14. What is the ratio of the CO2 emissions (% of total fuel combustion) in Small states in 1999 to that in 2000?
Offer a terse response. 1.07. What is the ratio of the CO2 emissions (% of total fuel combustion) in South Asia in 1999 to that in 2000?
Give a very brief answer. 1.09. What is the ratio of the CO2 emissions (% of total fuel combustion) of Georgia in 1999 to that in 2000?
Your response must be concise. 1.56. What is the difference between the highest and the second highest CO2 emissions (% of total fuel combustion) in Europe(developing only)?
Your response must be concise. 0.34. What is the difference between the highest and the second highest CO2 emissions (% of total fuel combustion) in Small states?
Your response must be concise. 1.82. What is the difference between the highest and the second highest CO2 emissions (% of total fuel combustion) of South Asia?
Make the answer very short. 0.15. What is the difference between the highest and the second highest CO2 emissions (% of total fuel combustion) in Georgia?
Provide a succinct answer. 0.81. What is the difference between the highest and the lowest CO2 emissions (% of total fuel combustion) in Europe(developing only)?
Your answer should be compact. 0.97. What is the difference between the highest and the lowest CO2 emissions (% of total fuel combustion) in Small states?
Your answer should be compact. 2.37. What is the difference between the highest and the lowest CO2 emissions (% of total fuel combustion) in South Asia?
Offer a very short reply. 1.32. What is the difference between the highest and the lowest CO2 emissions (% of total fuel combustion) in Georgia?
Offer a terse response. 3.72. 